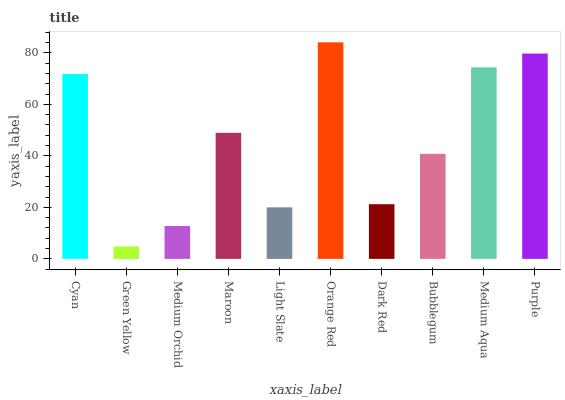Is Green Yellow the minimum?
Answer yes or no. Yes. Is Orange Red the maximum?
Answer yes or no. Yes. Is Medium Orchid the minimum?
Answer yes or no. No. Is Medium Orchid the maximum?
Answer yes or no. No. Is Medium Orchid greater than Green Yellow?
Answer yes or no. Yes. Is Green Yellow less than Medium Orchid?
Answer yes or no. Yes. Is Green Yellow greater than Medium Orchid?
Answer yes or no. No. Is Medium Orchid less than Green Yellow?
Answer yes or no. No. Is Maroon the high median?
Answer yes or no. Yes. Is Bubblegum the low median?
Answer yes or no. Yes. Is Dark Red the high median?
Answer yes or no. No. Is Purple the low median?
Answer yes or no. No. 